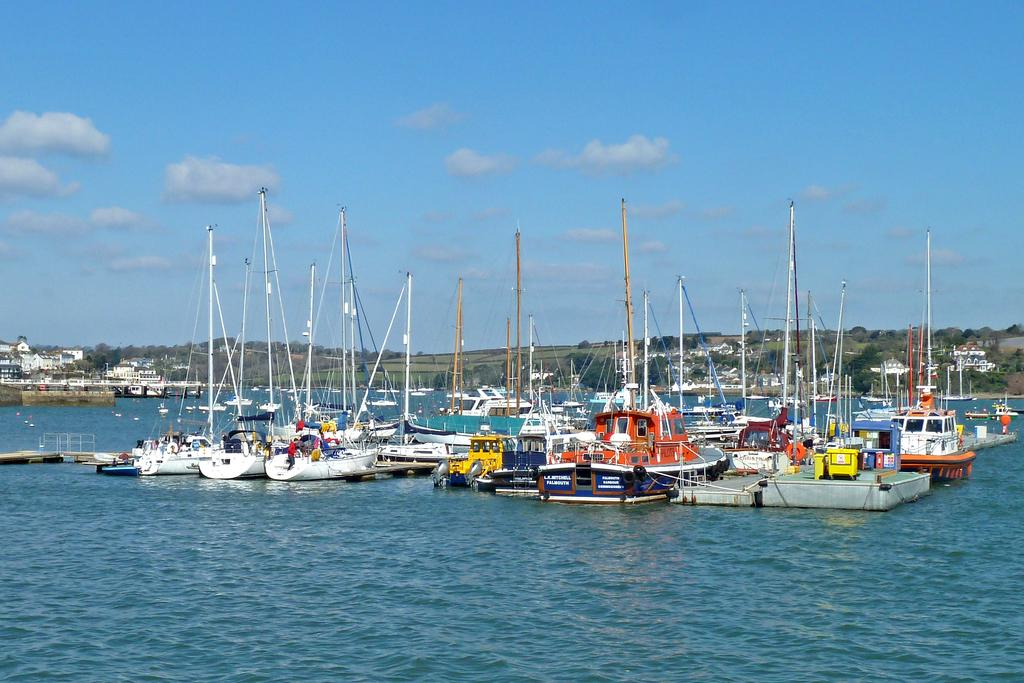What is on the surface of the water in the image? There are ships on the surface of the water in the image. What can be seen in the background of the image? There are buildings and trees in the background of the image. How would you describe the sky in the image? The sky is blue with clouds in the image. What type of shame can be seen on the ships in the image? There is no shame present in the image; it features ships on the water with buildings, trees, and a blue sky with clouds. What type of flame is visible on the trees in the image? There is no flame present in the image; it features ships on the water with buildings, trees, and a blue sky with clouds. 